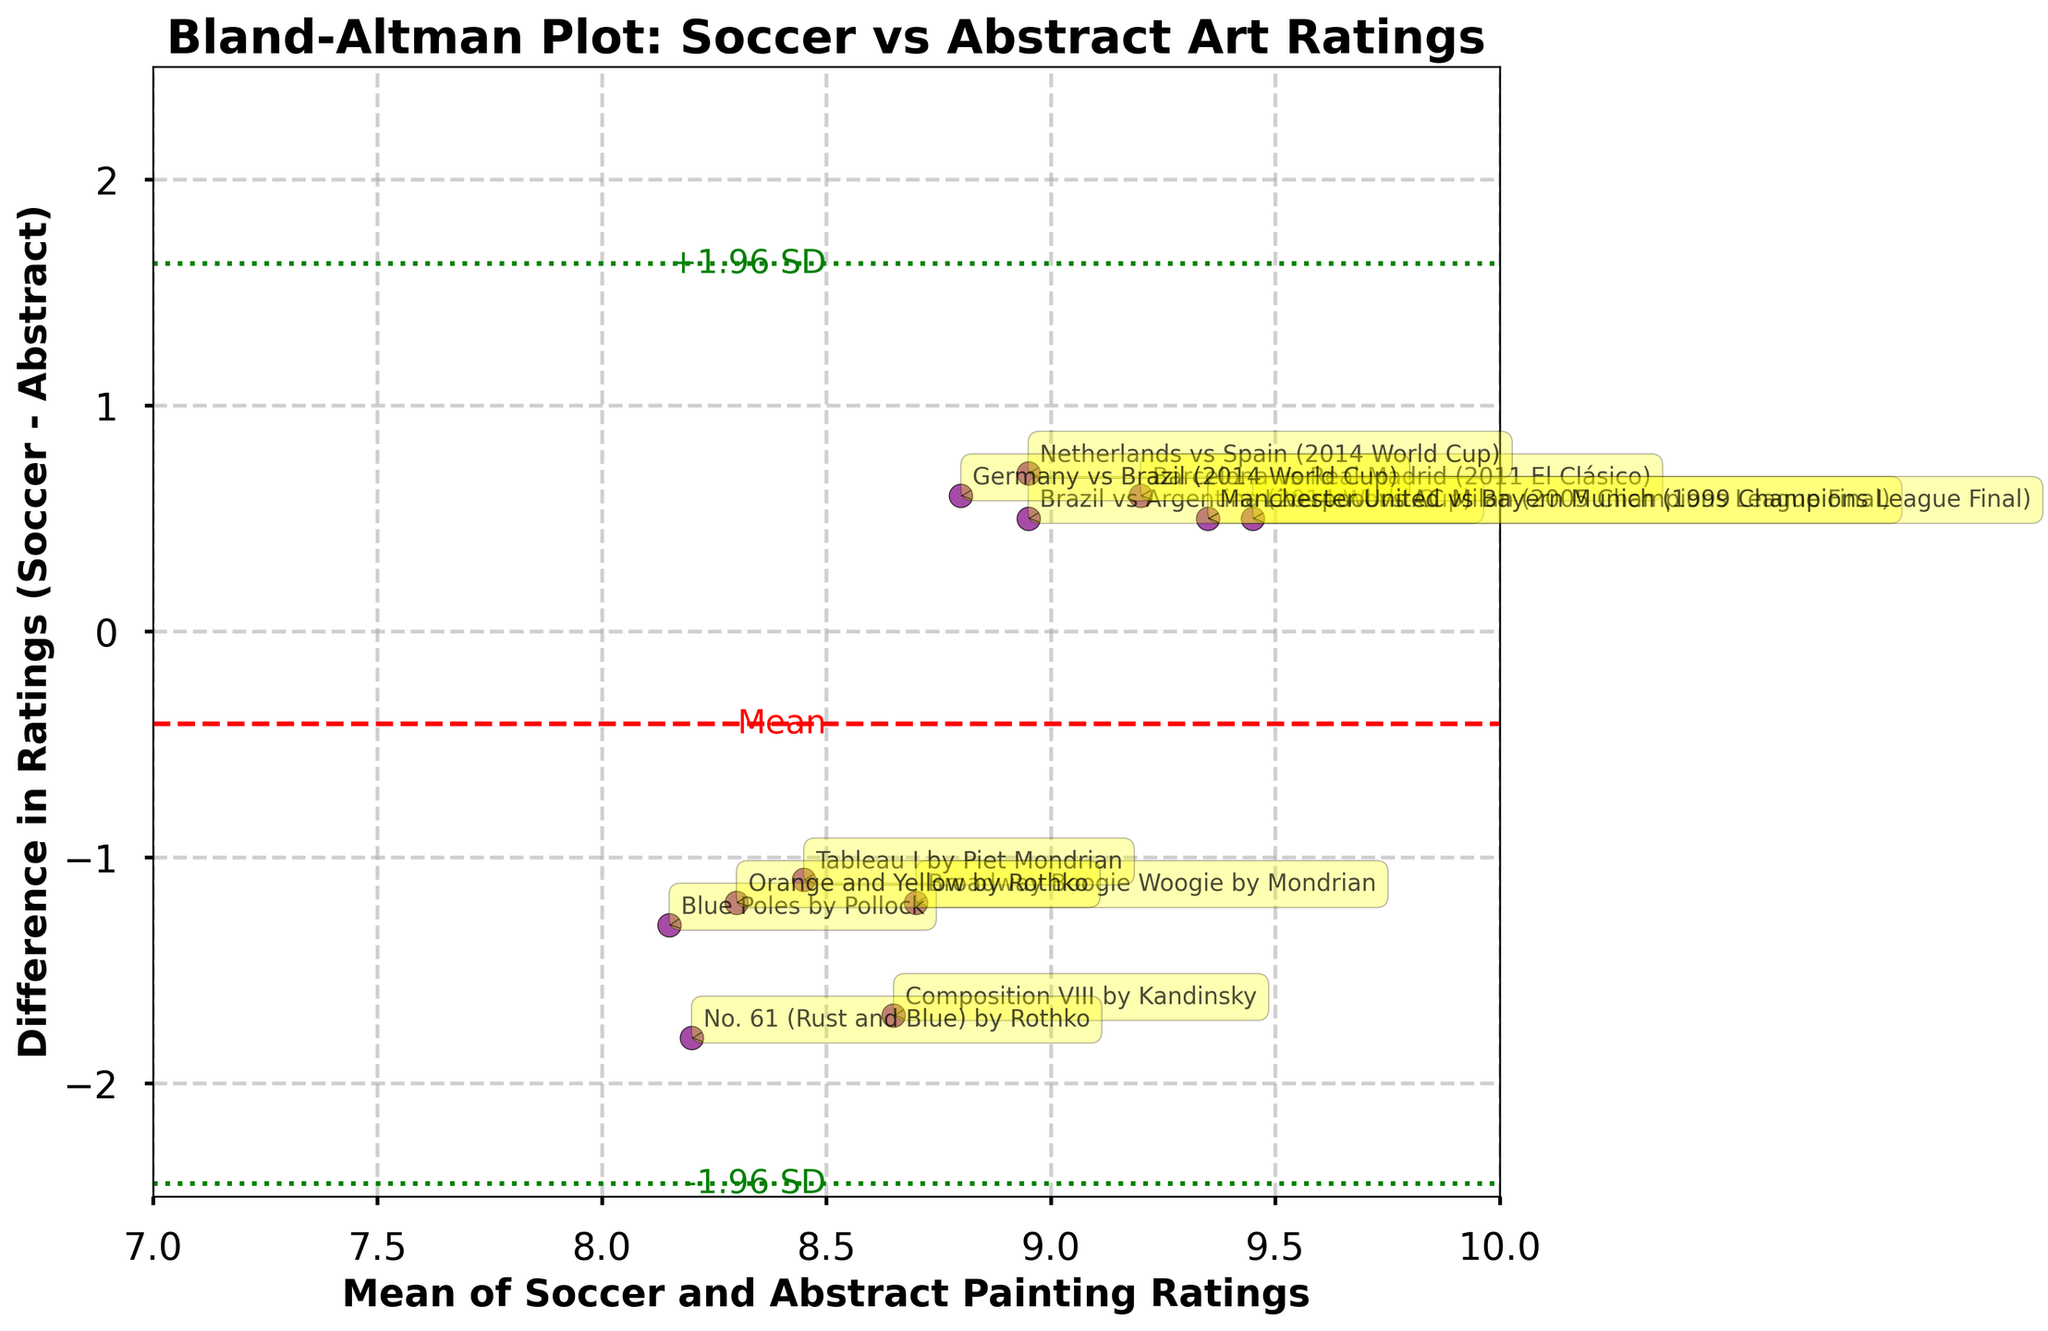What is the title of the plot? The title of the plot is prominently placed at the top of the figure, typically using a larger font size and bold typeface for emphasis. The title summarizes the content or purpose of the figure.
Answer: Bland-Altman Plot: Soccer vs Abstract Art Ratings How many data points are in the plot? The number of data points can be determined by counting each distinct point plotted on the figure. Each point usually represents an individual observation or data pair.
Answer: 12 What do the red dashed and green dotted lines represent? The red dashed line represents the mean difference between the two types of ratings. The green dotted lines mark the limits of agreement, which are mean difference plus and minus 1.96 times the standard deviation of the differences.
Answer: Mean difference and limits of agreement Which match/painting has the highest mean rating? To identify the highest mean rating, calculate the average for each data point by adding the soccer and painting ratings and dividing by two. The point with the highest computed mean is the answer.
Answer: Liverpool vs AC Milan (2005 Champions League Final) Which match/painting shows the greatest difference in ratings between soccer and abstract painting? Examine the vertical distances from the baseline of each data point. The point furthest from the baseline (in absolute terms) has the largest difference between soccer and abstract painting ratings.
Answer: "No. 61 (Rust and Blue)" by Rothko What is the mean difference between the soccer and painting ratings? The mean difference is represented by the red dashed line on the y-axis. This numeric value is typically labeled directly on the figure for clarity.
Answer: 0.25 Describe the positions of "Brazil vs Argentina (2014 World Cup)” and "Composition VIII" by Kandinsky. To describe the positions, locate both points on the xy-plane by referencing their mean ratings on the x-axis and differences on the y-axis. Place coordinates accordingly.
Answer: "Brazil vs Argentina" is near (8.95, 0.5); "Composition VIII" is near (8.65, -1.7) Are the differences between soccer and abstract painting ratings consistent across the range of average ratings? Assess the scatter of points around the mean difference line. If points are widely spread around the mean line and limits of agreement, consistency is low; otherwise, consistency is high.
Answer: No Which painting has a higher rating than its corresponding soccer match? Compare individual points to see where the abstract painting rating exceeds the soccer rating. Check where points fall below the zero difference line.
Answer: "Composition VIII" by Kandinsky and "No. 61 (Rust and Blue)" by Rothko How do the ratings of "Germany vs Brazil (2014 World Cup)” and "Tableau I" by Piet Mondrian compare? Locate both points and check their positions relative to each other, focusing on mean ratings on the x-axis and rating differences on the y-axis.
Answer: "Germany vs Brazil" has a higher mean rating but a positive difference, whereas "Tableau I" has a lower mean rating but a negative difference 